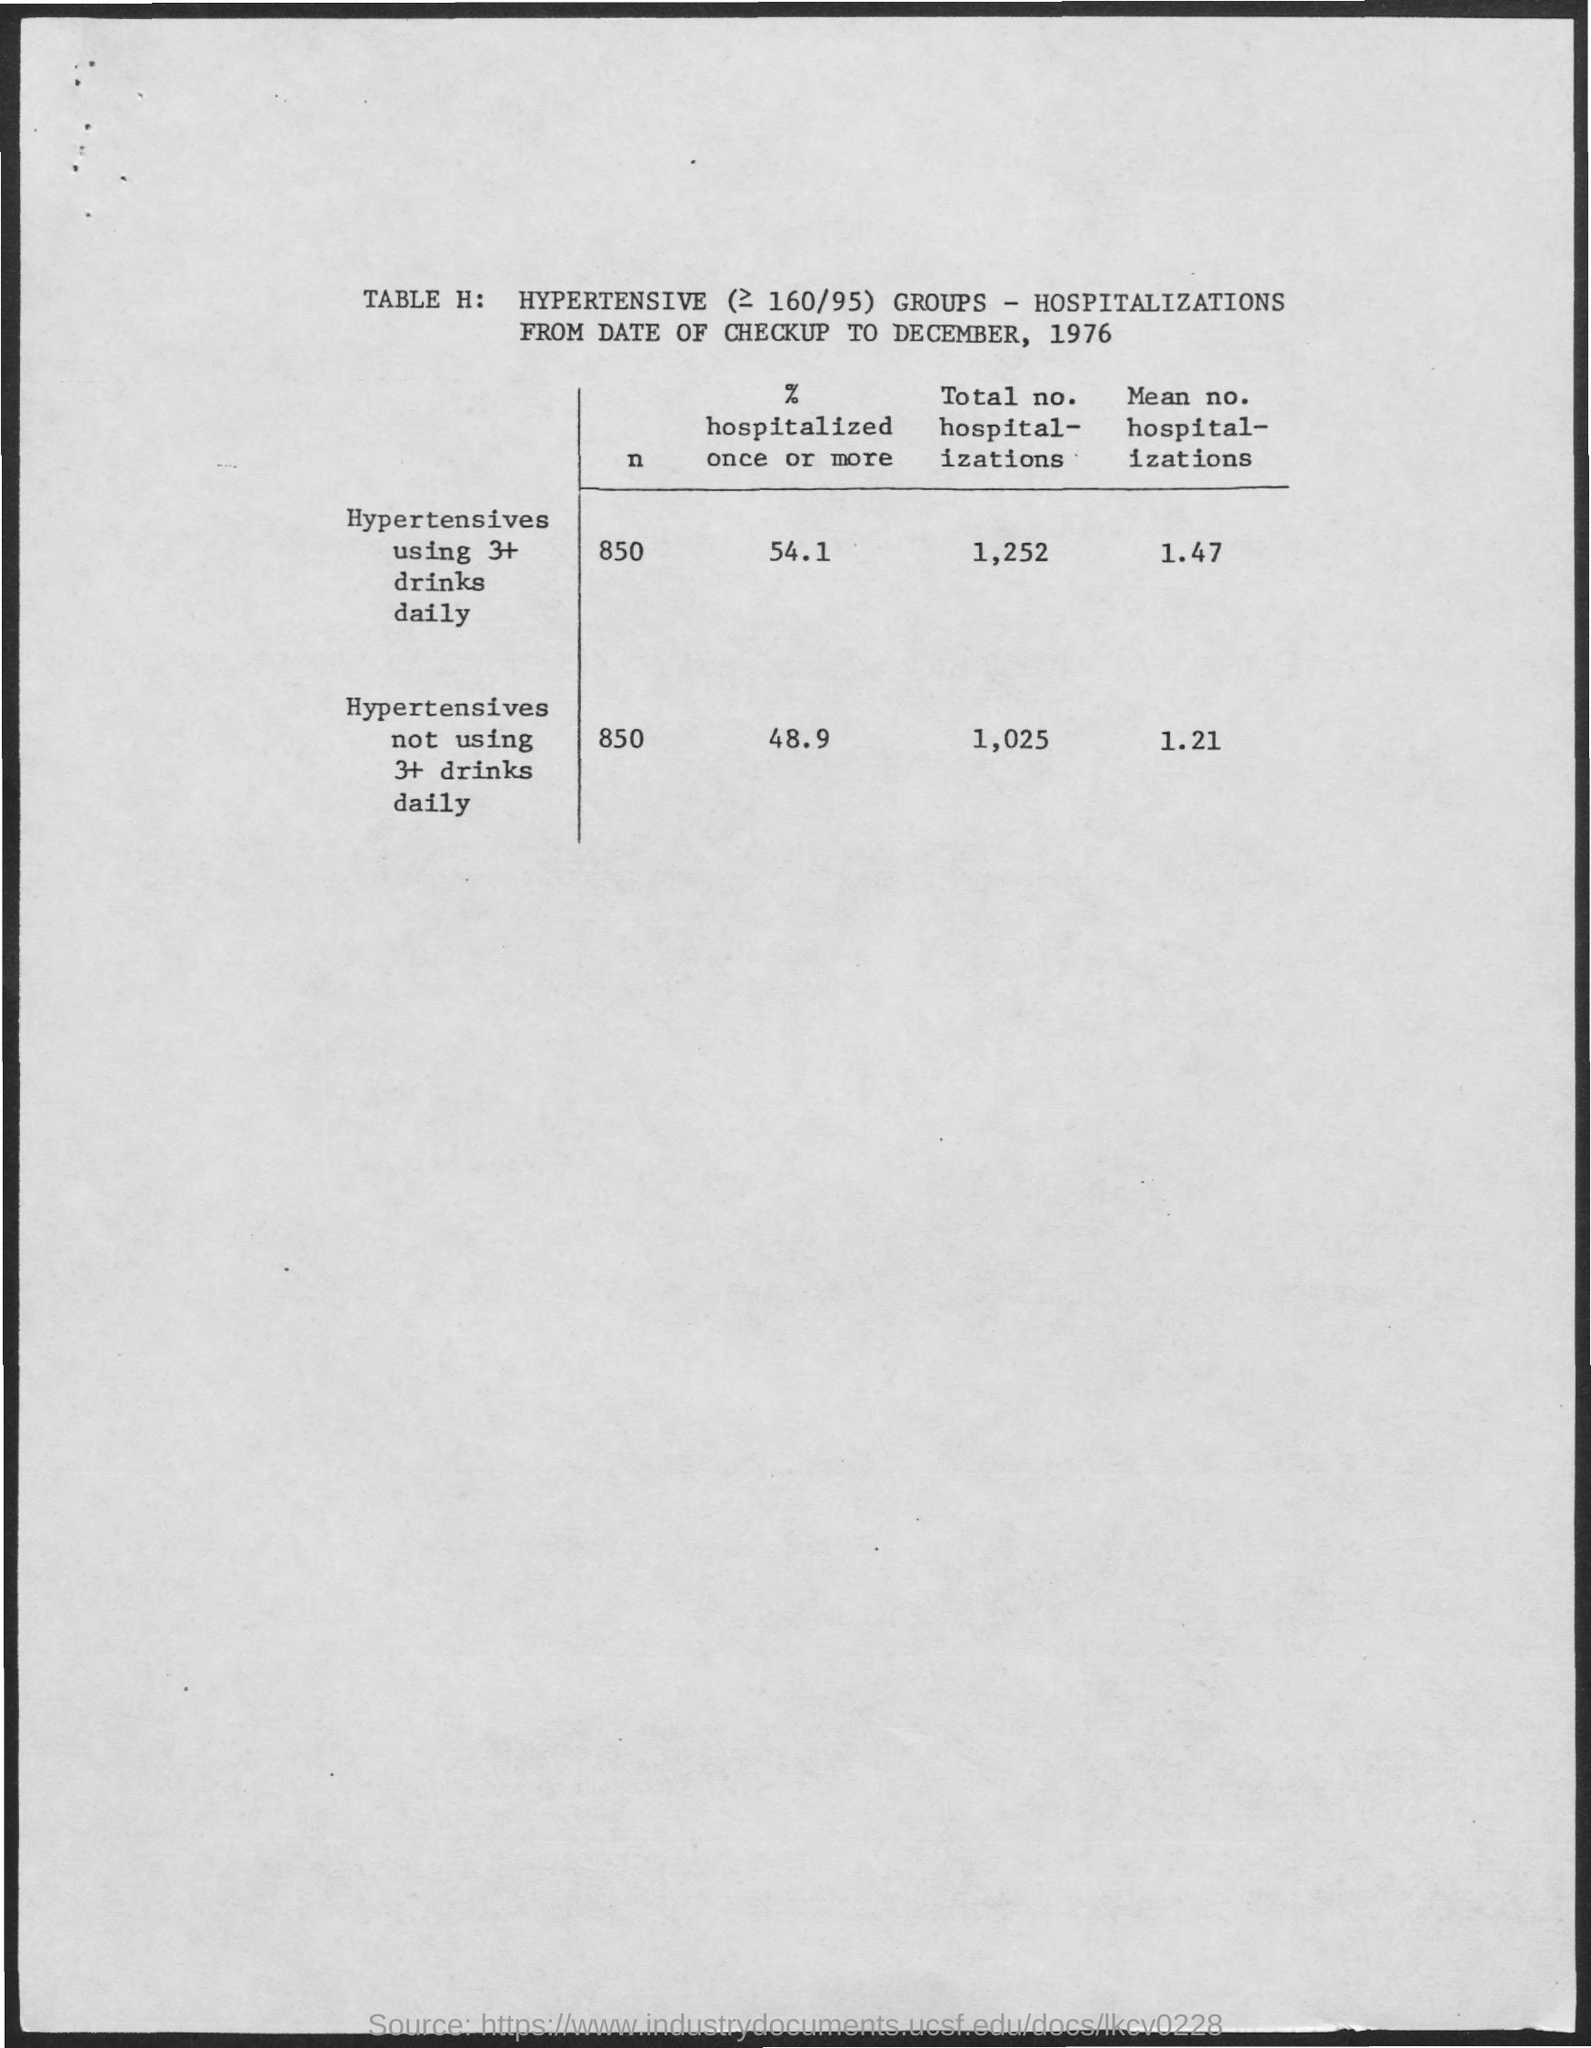What is the value of n for Hypertensives using 3+ drinks daily?
Make the answer very short. 850. 